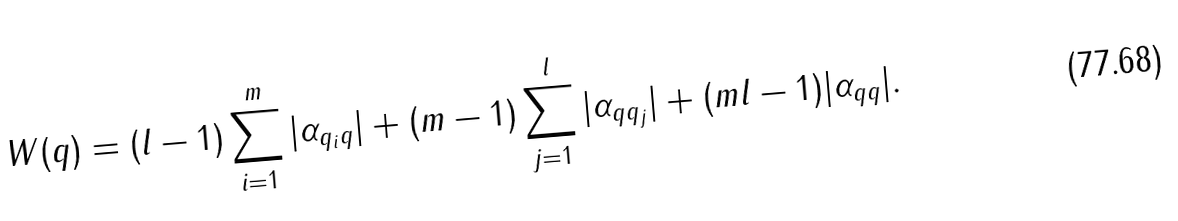Convert formula to latex. <formula><loc_0><loc_0><loc_500><loc_500>W ( q ) = ( l - 1 ) \sum _ { i = 1 } ^ { m } | \alpha _ { q _ { i } q } | + ( m - 1 ) \sum _ { j = 1 } ^ { l } | \alpha _ { q q _ { j } } | + ( m l - 1 ) | \alpha _ { q q } | .</formula> 